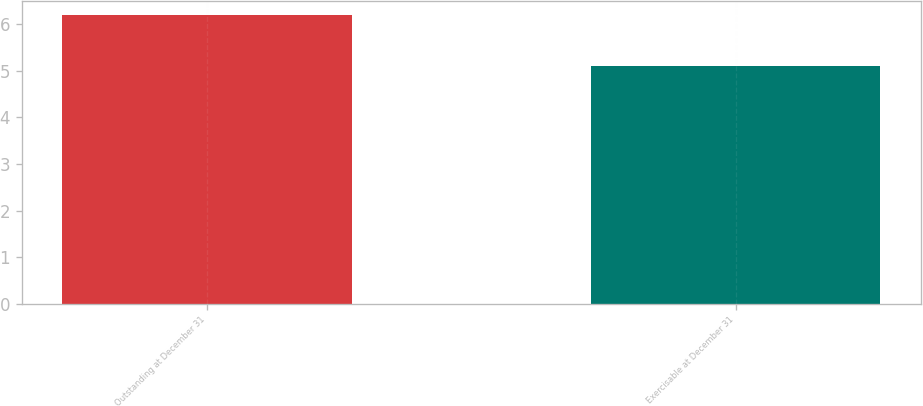Convert chart to OTSL. <chart><loc_0><loc_0><loc_500><loc_500><bar_chart><fcel>Outstanding at December 31<fcel>Exercisable at December 31<nl><fcel>6.2<fcel>5.1<nl></chart> 